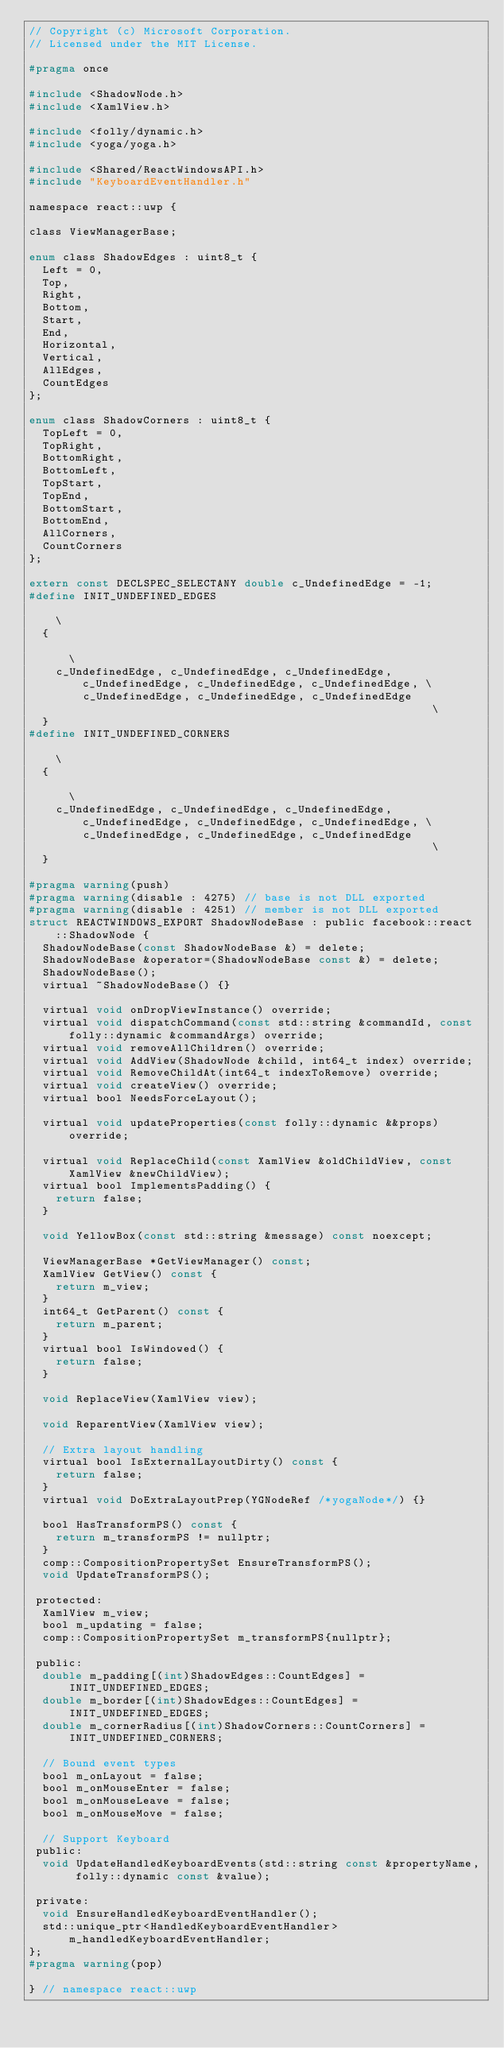Convert code to text. <code><loc_0><loc_0><loc_500><loc_500><_C_>// Copyright (c) Microsoft Corporation.
// Licensed under the MIT License.

#pragma once

#include <ShadowNode.h>
#include <XamlView.h>

#include <folly/dynamic.h>
#include <yoga/yoga.h>

#include <Shared/ReactWindowsAPI.h>
#include "KeyboardEventHandler.h"

namespace react::uwp {

class ViewManagerBase;

enum class ShadowEdges : uint8_t {
  Left = 0,
  Top,
  Right,
  Bottom,
  Start,
  End,
  Horizontal,
  Vertical,
  AllEdges,
  CountEdges
};

enum class ShadowCorners : uint8_t {
  TopLeft = 0,
  TopRight,
  BottomRight,
  BottomLeft,
  TopStart,
  TopEnd,
  BottomStart,
  BottomEnd,
  AllCorners,
  CountCorners
};

extern const DECLSPEC_SELECTANY double c_UndefinedEdge = -1;
#define INIT_UNDEFINED_EDGES                                                                              \
  {                                                                                                       \
    c_UndefinedEdge, c_UndefinedEdge, c_UndefinedEdge, c_UndefinedEdge, c_UndefinedEdge, c_UndefinedEdge, \
        c_UndefinedEdge, c_UndefinedEdge, c_UndefinedEdge                                                 \
  }
#define INIT_UNDEFINED_CORNERS                                                                            \
  {                                                                                                       \
    c_UndefinedEdge, c_UndefinedEdge, c_UndefinedEdge, c_UndefinedEdge, c_UndefinedEdge, c_UndefinedEdge, \
        c_UndefinedEdge, c_UndefinedEdge, c_UndefinedEdge                                                 \
  }

#pragma warning(push)
#pragma warning(disable : 4275) // base is not DLL exported
#pragma warning(disable : 4251) // member is not DLL exported
struct REACTWINDOWS_EXPORT ShadowNodeBase : public facebook::react::ShadowNode {
  ShadowNodeBase(const ShadowNodeBase &) = delete;
  ShadowNodeBase &operator=(ShadowNodeBase const &) = delete;
  ShadowNodeBase();
  virtual ~ShadowNodeBase() {}

  virtual void onDropViewInstance() override;
  virtual void dispatchCommand(const std::string &commandId, const folly::dynamic &commandArgs) override;
  virtual void removeAllChildren() override;
  virtual void AddView(ShadowNode &child, int64_t index) override;
  virtual void RemoveChildAt(int64_t indexToRemove) override;
  virtual void createView() override;
  virtual bool NeedsForceLayout();

  virtual void updateProperties(const folly::dynamic &&props) override;

  virtual void ReplaceChild(const XamlView &oldChildView, const XamlView &newChildView);
  virtual bool ImplementsPadding() {
    return false;
  }

  void YellowBox(const std::string &message) const noexcept;

  ViewManagerBase *GetViewManager() const;
  XamlView GetView() const {
    return m_view;
  }
  int64_t GetParent() const {
    return m_parent;
  }
  virtual bool IsWindowed() {
    return false;
  }

  void ReplaceView(XamlView view);

  void ReparentView(XamlView view);

  // Extra layout handling
  virtual bool IsExternalLayoutDirty() const {
    return false;
  }
  virtual void DoExtraLayoutPrep(YGNodeRef /*yogaNode*/) {}

  bool HasTransformPS() const {
    return m_transformPS != nullptr;
  }
  comp::CompositionPropertySet EnsureTransformPS();
  void UpdateTransformPS();

 protected:
  XamlView m_view;
  bool m_updating = false;
  comp::CompositionPropertySet m_transformPS{nullptr};

 public:
  double m_padding[(int)ShadowEdges::CountEdges] = INIT_UNDEFINED_EDGES;
  double m_border[(int)ShadowEdges::CountEdges] = INIT_UNDEFINED_EDGES;
  double m_cornerRadius[(int)ShadowCorners::CountCorners] = INIT_UNDEFINED_CORNERS;

  // Bound event types
  bool m_onLayout = false;
  bool m_onMouseEnter = false;
  bool m_onMouseLeave = false;
  bool m_onMouseMove = false;

  // Support Keyboard
 public:
  void UpdateHandledKeyboardEvents(std::string const &propertyName, folly::dynamic const &value);

 private:
  void EnsureHandledKeyboardEventHandler();
  std::unique_ptr<HandledKeyboardEventHandler> m_handledKeyboardEventHandler;
};
#pragma warning(pop)

} // namespace react::uwp
</code> 